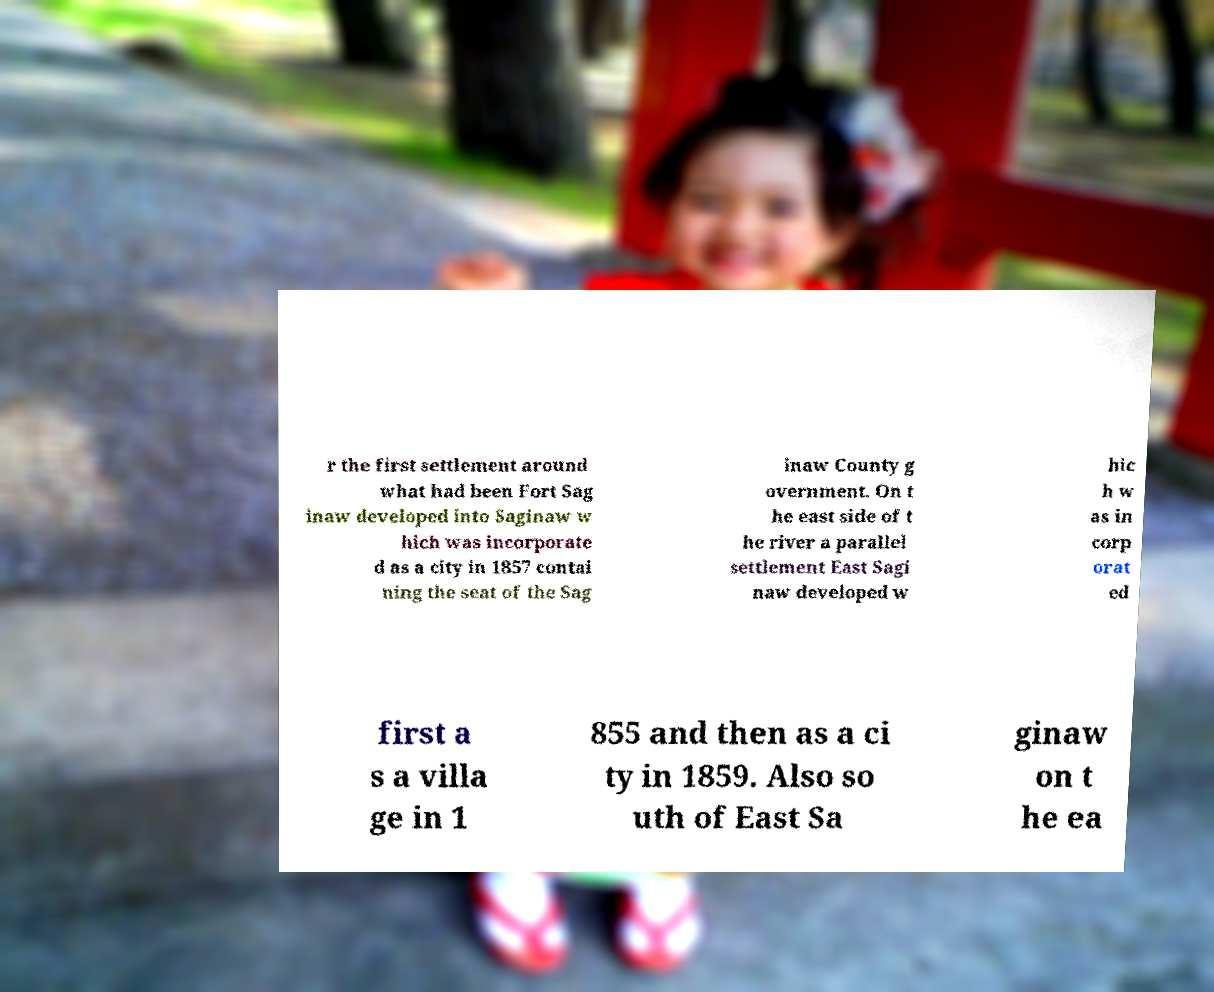There's text embedded in this image that I need extracted. Can you transcribe it verbatim? r the first settlement around what had been Fort Sag inaw developed into Saginaw w hich was incorporate d as a city in 1857 contai ning the seat of the Sag inaw County g overnment. On t he east side of t he river a parallel settlement East Sagi naw developed w hic h w as in corp orat ed first a s a villa ge in 1 855 and then as a ci ty in 1859. Also so uth of East Sa ginaw on t he ea 